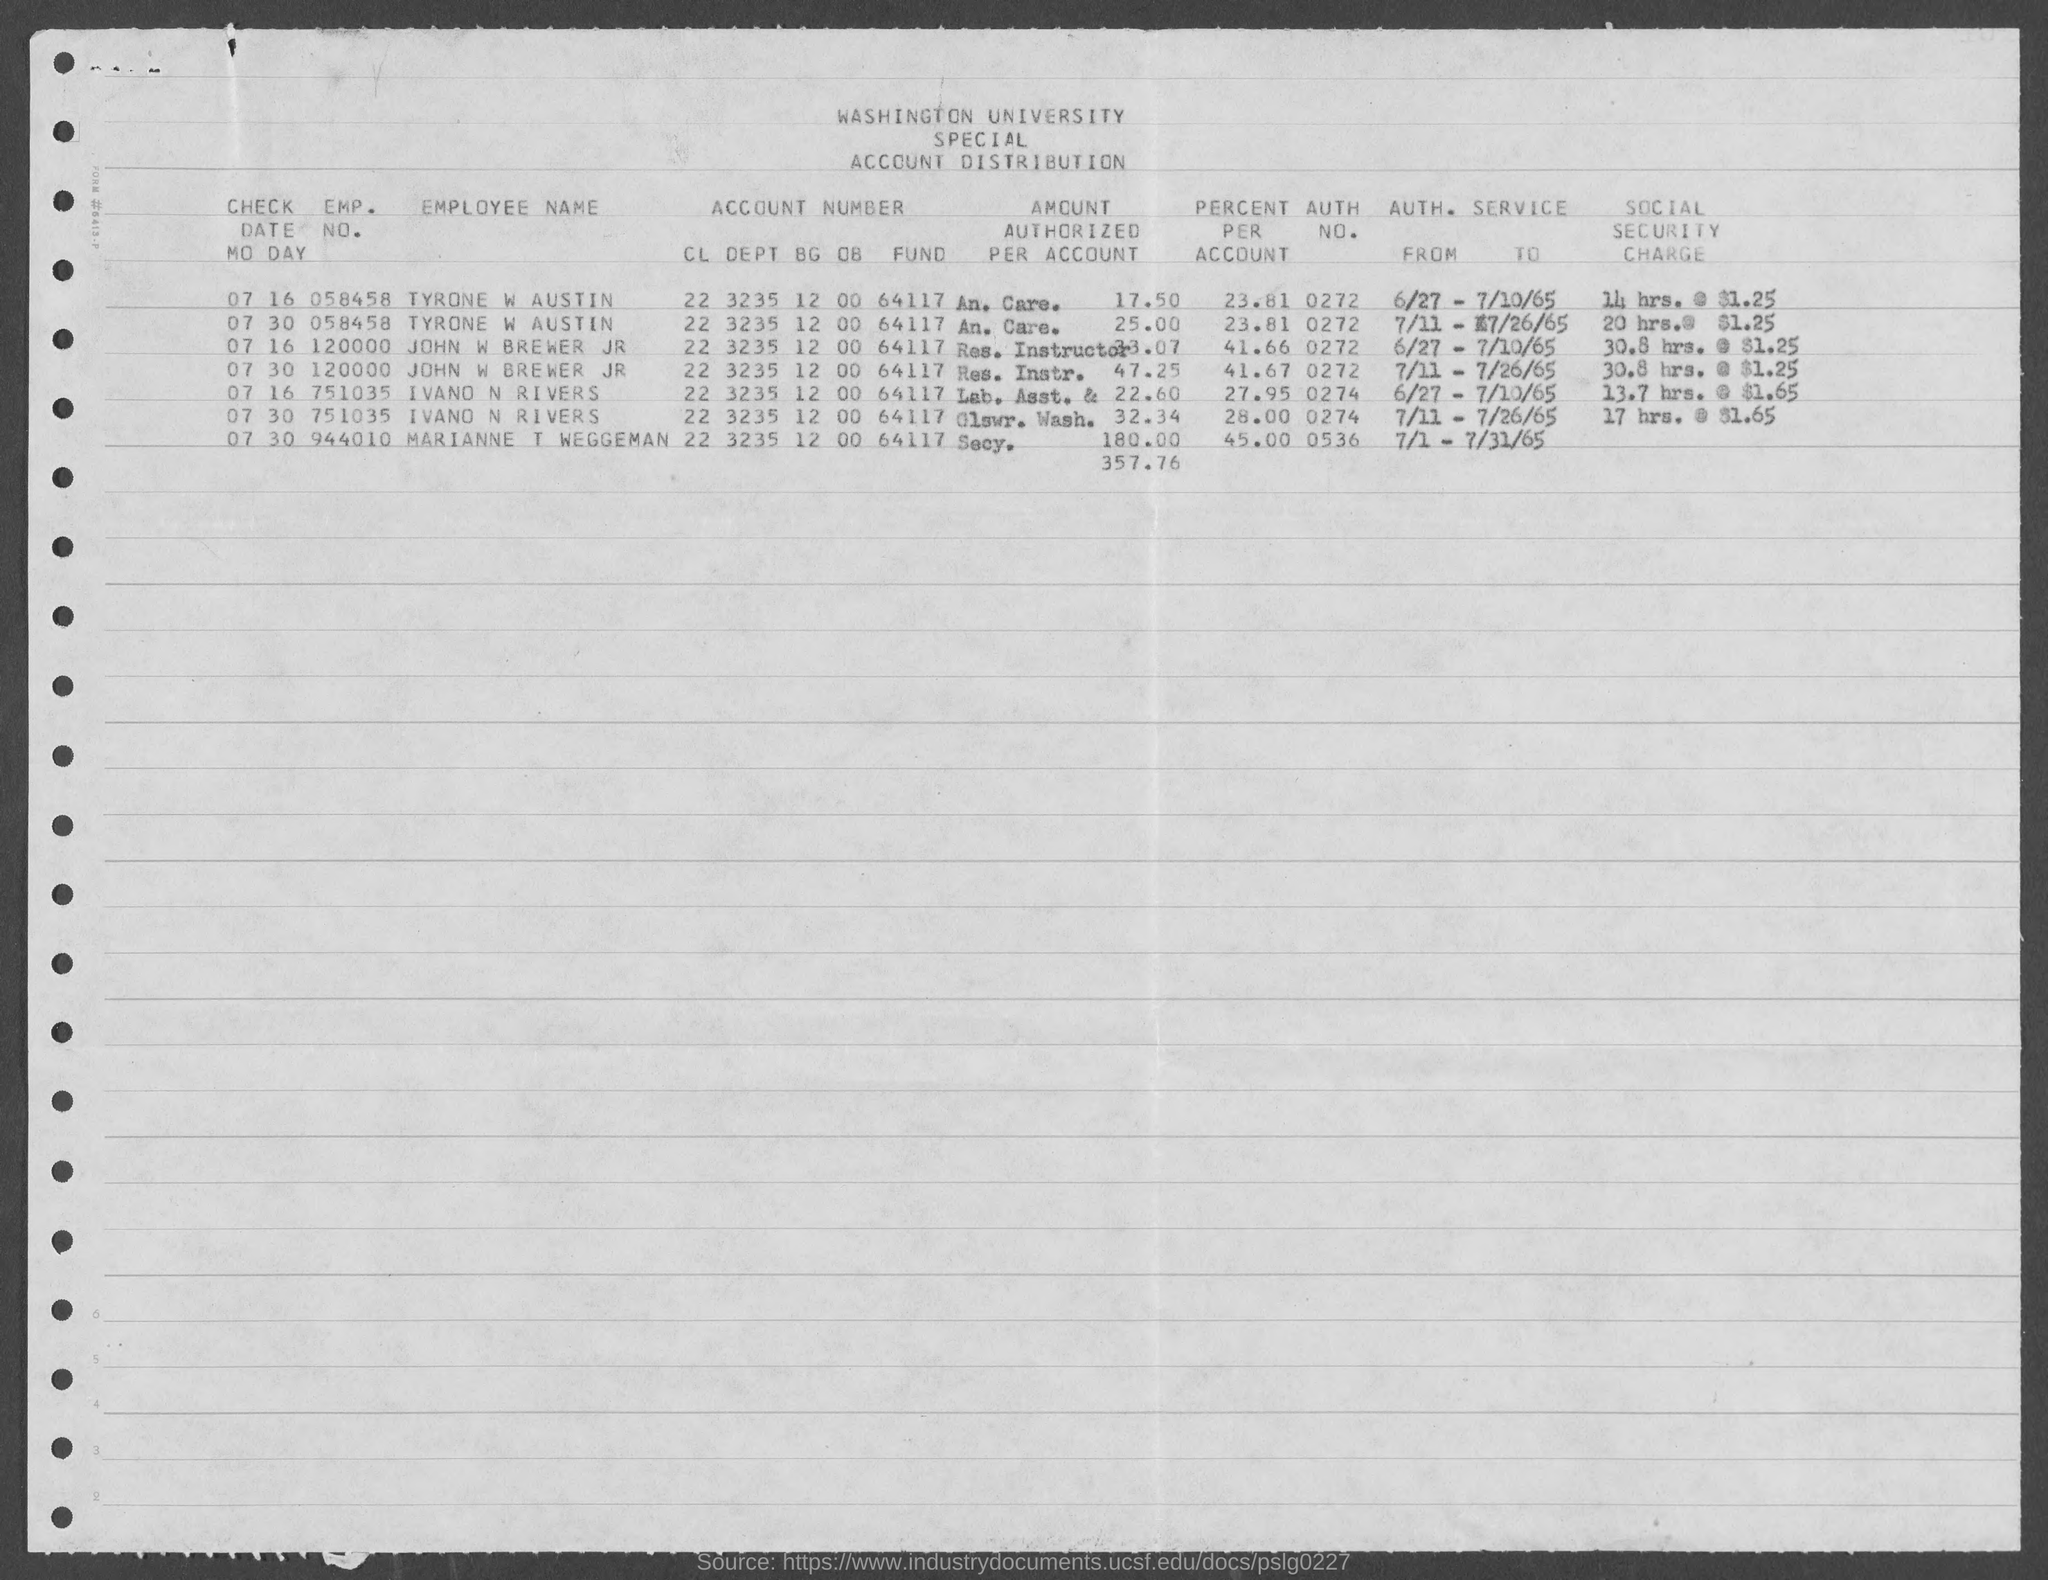What is the emp. no.  of tyrone w austin ?
Your answer should be compact. 058458. What is the emp. no. of john w brewer jr ?
Provide a short and direct response. 120000. What is the emp. no. of ivano n rivers ?
Your response must be concise. 751035. What is the emp. no. of marianne t weggeman ?
Offer a very short reply. 944010. What is the auth. no. of tyrone w austin ?
Keep it short and to the point. 0272. What is the auth. no. of  john w brewer jr?
Provide a short and direct response. 0272. What is the percent per account of tyrone w austin ?
Ensure brevity in your answer.  23.81. What is the percent per account of marianne t weggeman ?
Provide a short and direct response. 45.00. 